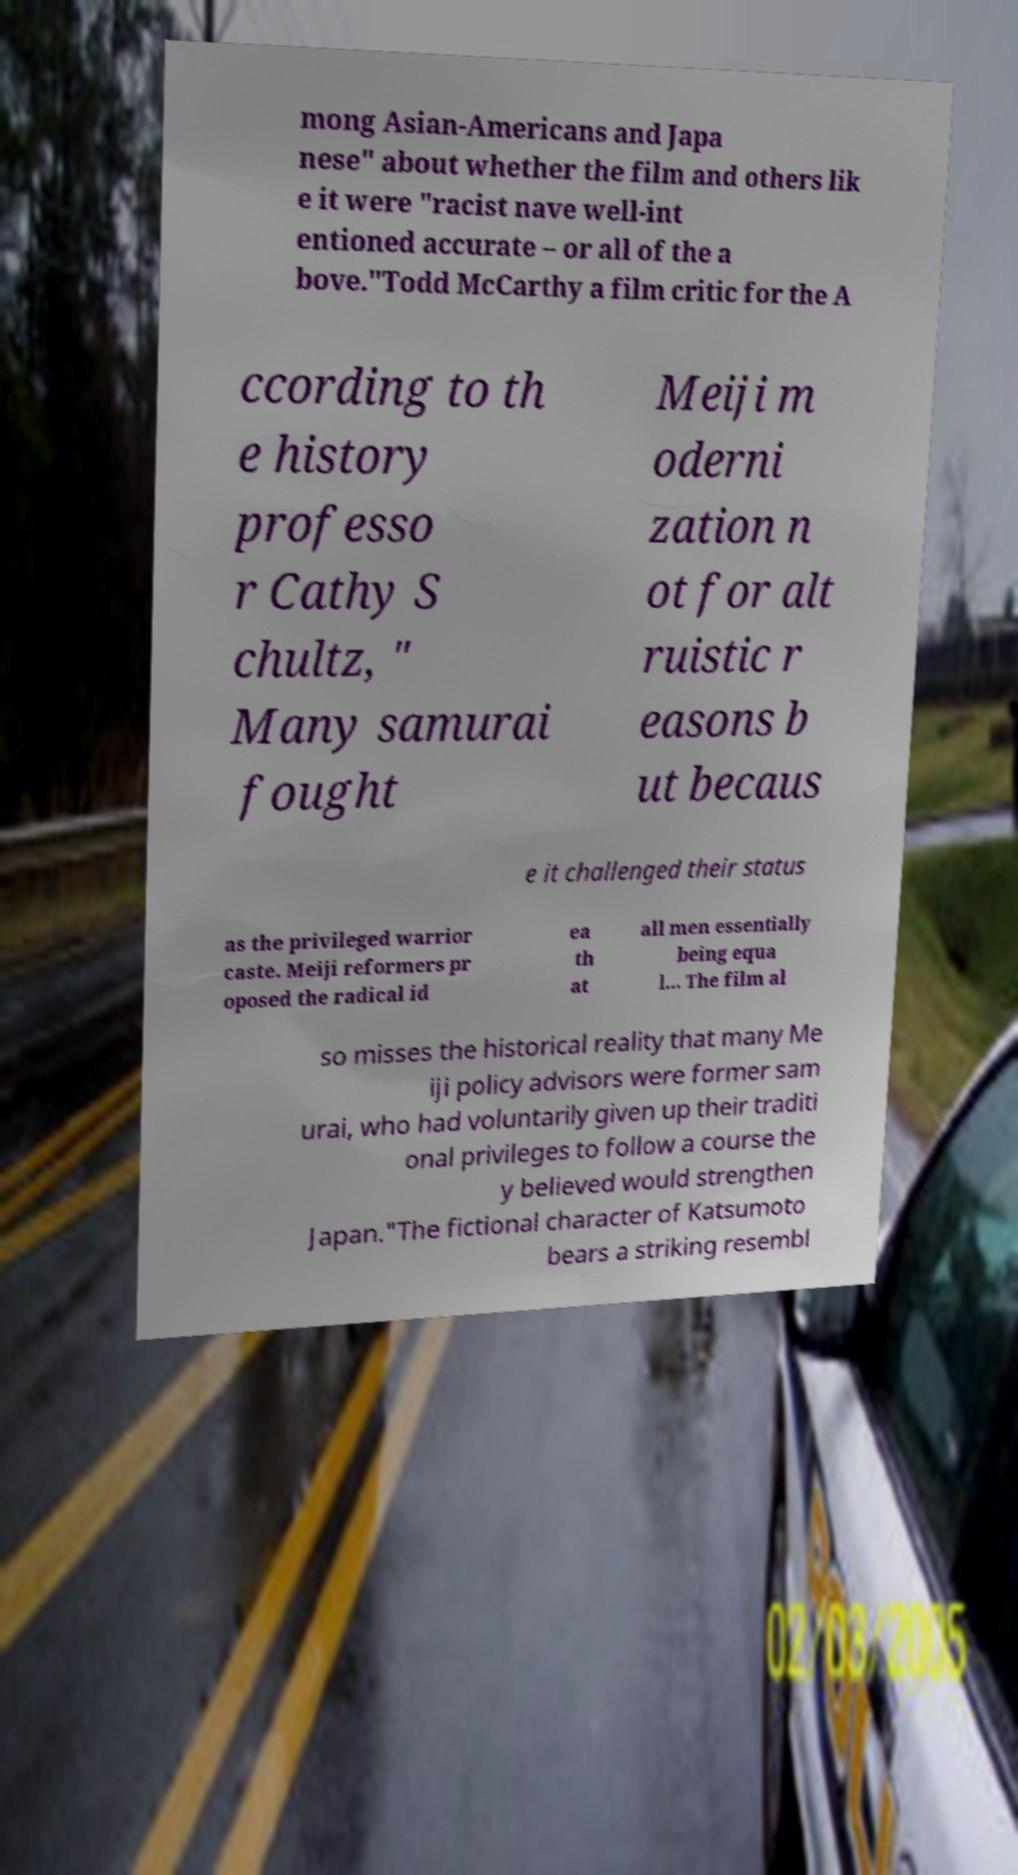Can you accurately transcribe the text from the provided image for me? mong Asian-Americans and Japa nese" about whether the film and others lik e it were "racist nave well-int entioned accurate – or all of the a bove."Todd McCarthy a film critic for the A ccording to th e history professo r Cathy S chultz, " Many samurai fought Meiji m oderni zation n ot for alt ruistic r easons b ut becaus e it challenged their status as the privileged warrior caste. Meiji reformers pr oposed the radical id ea th at all men essentially being equa l... The film al so misses the historical reality that many Me iji policy advisors were former sam urai, who had voluntarily given up their traditi onal privileges to follow a course the y believed would strengthen Japan."The fictional character of Katsumoto bears a striking resembl 